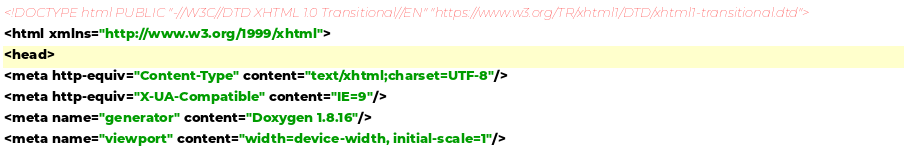<code> <loc_0><loc_0><loc_500><loc_500><_HTML_><!DOCTYPE html PUBLIC "-//W3C//DTD XHTML 1.0 Transitional//EN" "https://www.w3.org/TR/xhtml1/DTD/xhtml1-transitional.dtd">
<html xmlns="http://www.w3.org/1999/xhtml">
<head>
<meta http-equiv="Content-Type" content="text/xhtml;charset=UTF-8"/>
<meta http-equiv="X-UA-Compatible" content="IE=9"/>
<meta name="generator" content="Doxygen 1.8.16"/>
<meta name="viewport" content="width=device-width, initial-scale=1"/></code> 